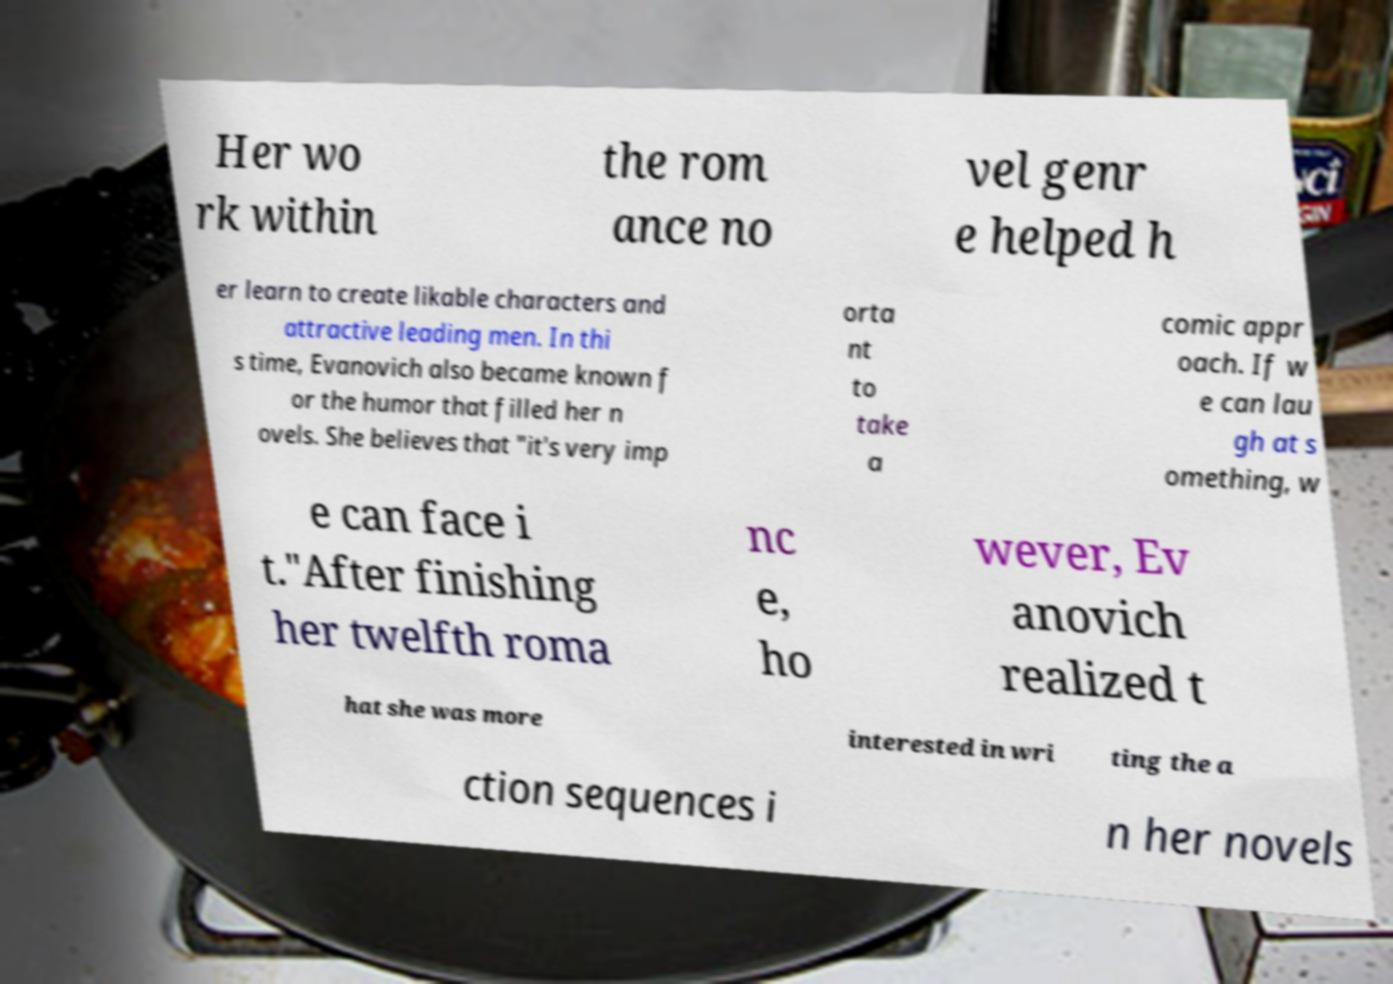Please identify and transcribe the text found in this image. Her wo rk within the rom ance no vel genr e helped h er learn to create likable characters and attractive leading men. In thi s time, Evanovich also became known f or the humor that filled her n ovels. She believes that "it's very imp orta nt to take a comic appr oach. If w e can lau gh at s omething, w e can face i t."After finishing her twelfth roma nc e, ho wever, Ev anovich realized t hat she was more interested in wri ting the a ction sequences i n her novels 